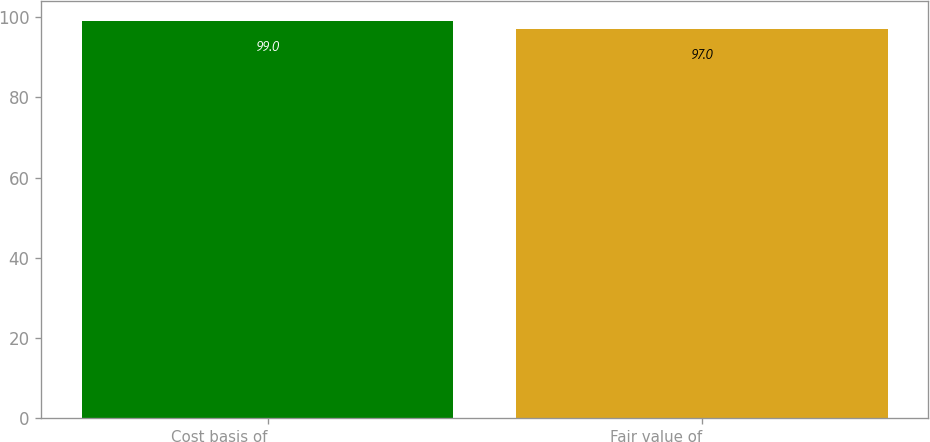Convert chart to OTSL. <chart><loc_0><loc_0><loc_500><loc_500><bar_chart><fcel>Cost basis of<fcel>Fair value of<nl><fcel>99<fcel>97<nl></chart> 